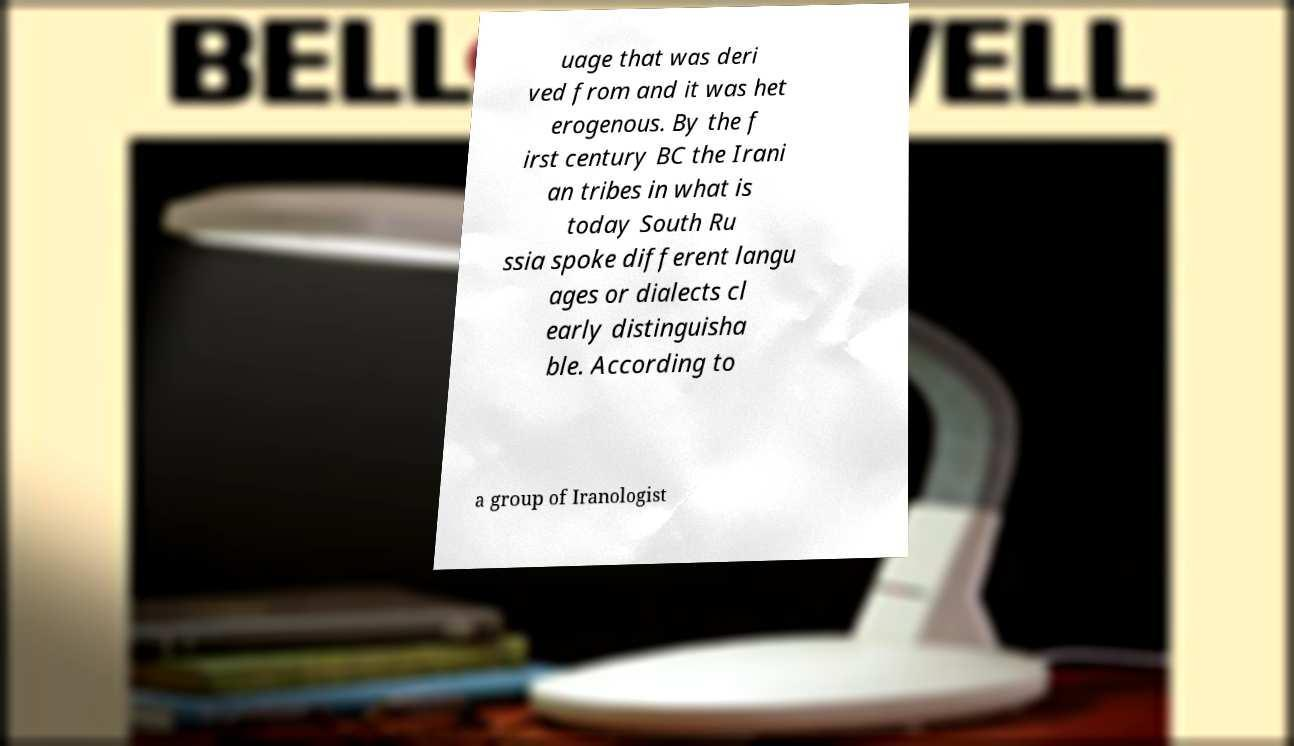For documentation purposes, I need the text within this image transcribed. Could you provide that? uage that was deri ved from and it was het erogenous. By the f irst century BC the Irani an tribes in what is today South Ru ssia spoke different langu ages or dialects cl early distinguisha ble. According to a group of Iranologist 